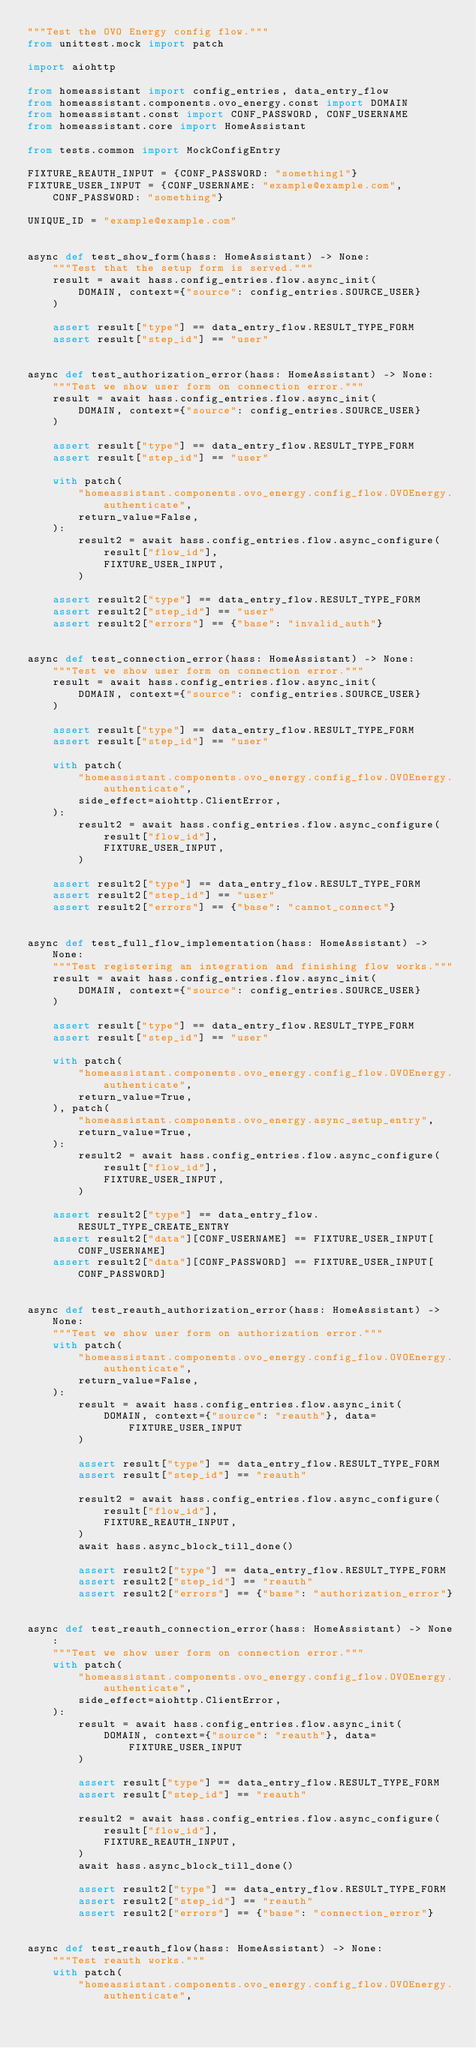<code> <loc_0><loc_0><loc_500><loc_500><_Python_>"""Test the OVO Energy config flow."""
from unittest.mock import patch

import aiohttp

from homeassistant import config_entries, data_entry_flow
from homeassistant.components.ovo_energy.const import DOMAIN
from homeassistant.const import CONF_PASSWORD, CONF_USERNAME
from homeassistant.core import HomeAssistant

from tests.common import MockConfigEntry

FIXTURE_REAUTH_INPUT = {CONF_PASSWORD: "something1"}
FIXTURE_USER_INPUT = {CONF_USERNAME: "example@example.com", CONF_PASSWORD: "something"}

UNIQUE_ID = "example@example.com"


async def test_show_form(hass: HomeAssistant) -> None:
    """Test that the setup form is served."""
    result = await hass.config_entries.flow.async_init(
        DOMAIN, context={"source": config_entries.SOURCE_USER}
    )

    assert result["type"] == data_entry_flow.RESULT_TYPE_FORM
    assert result["step_id"] == "user"


async def test_authorization_error(hass: HomeAssistant) -> None:
    """Test we show user form on connection error."""
    result = await hass.config_entries.flow.async_init(
        DOMAIN, context={"source": config_entries.SOURCE_USER}
    )

    assert result["type"] == data_entry_flow.RESULT_TYPE_FORM
    assert result["step_id"] == "user"

    with patch(
        "homeassistant.components.ovo_energy.config_flow.OVOEnergy.authenticate",
        return_value=False,
    ):
        result2 = await hass.config_entries.flow.async_configure(
            result["flow_id"],
            FIXTURE_USER_INPUT,
        )

    assert result2["type"] == data_entry_flow.RESULT_TYPE_FORM
    assert result2["step_id"] == "user"
    assert result2["errors"] == {"base": "invalid_auth"}


async def test_connection_error(hass: HomeAssistant) -> None:
    """Test we show user form on connection error."""
    result = await hass.config_entries.flow.async_init(
        DOMAIN, context={"source": config_entries.SOURCE_USER}
    )

    assert result["type"] == data_entry_flow.RESULT_TYPE_FORM
    assert result["step_id"] == "user"

    with patch(
        "homeassistant.components.ovo_energy.config_flow.OVOEnergy.authenticate",
        side_effect=aiohttp.ClientError,
    ):
        result2 = await hass.config_entries.flow.async_configure(
            result["flow_id"],
            FIXTURE_USER_INPUT,
        )

    assert result2["type"] == data_entry_flow.RESULT_TYPE_FORM
    assert result2["step_id"] == "user"
    assert result2["errors"] == {"base": "cannot_connect"}


async def test_full_flow_implementation(hass: HomeAssistant) -> None:
    """Test registering an integration and finishing flow works."""
    result = await hass.config_entries.flow.async_init(
        DOMAIN, context={"source": config_entries.SOURCE_USER}
    )

    assert result["type"] == data_entry_flow.RESULT_TYPE_FORM
    assert result["step_id"] == "user"

    with patch(
        "homeassistant.components.ovo_energy.config_flow.OVOEnergy.authenticate",
        return_value=True,
    ), patch(
        "homeassistant.components.ovo_energy.async_setup_entry",
        return_value=True,
    ):
        result2 = await hass.config_entries.flow.async_configure(
            result["flow_id"],
            FIXTURE_USER_INPUT,
        )

    assert result2["type"] == data_entry_flow.RESULT_TYPE_CREATE_ENTRY
    assert result2["data"][CONF_USERNAME] == FIXTURE_USER_INPUT[CONF_USERNAME]
    assert result2["data"][CONF_PASSWORD] == FIXTURE_USER_INPUT[CONF_PASSWORD]


async def test_reauth_authorization_error(hass: HomeAssistant) -> None:
    """Test we show user form on authorization error."""
    with patch(
        "homeassistant.components.ovo_energy.config_flow.OVOEnergy.authenticate",
        return_value=False,
    ):
        result = await hass.config_entries.flow.async_init(
            DOMAIN, context={"source": "reauth"}, data=FIXTURE_USER_INPUT
        )

        assert result["type"] == data_entry_flow.RESULT_TYPE_FORM
        assert result["step_id"] == "reauth"

        result2 = await hass.config_entries.flow.async_configure(
            result["flow_id"],
            FIXTURE_REAUTH_INPUT,
        )
        await hass.async_block_till_done()

        assert result2["type"] == data_entry_flow.RESULT_TYPE_FORM
        assert result2["step_id"] == "reauth"
        assert result2["errors"] == {"base": "authorization_error"}


async def test_reauth_connection_error(hass: HomeAssistant) -> None:
    """Test we show user form on connection error."""
    with patch(
        "homeassistant.components.ovo_energy.config_flow.OVOEnergy.authenticate",
        side_effect=aiohttp.ClientError,
    ):
        result = await hass.config_entries.flow.async_init(
            DOMAIN, context={"source": "reauth"}, data=FIXTURE_USER_INPUT
        )

        assert result["type"] == data_entry_flow.RESULT_TYPE_FORM
        assert result["step_id"] == "reauth"

        result2 = await hass.config_entries.flow.async_configure(
            result["flow_id"],
            FIXTURE_REAUTH_INPUT,
        )
        await hass.async_block_till_done()

        assert result2["type"] == data_entry_flow.RESULT_TYPE_FORM
        assert result2["step_id"] == "reauth"
        assert result2["errors"] == {"base": "connection_error"}


async def test_reauth_flow(hass: HomeAssistant) -> None:
    """Test reauth works."""
    with patch(
        "homeassistant.components.ovo_energy.config_flow.OVOEnergy.authenticate",</code> 